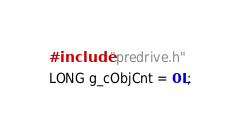Convert code to text. <code><loc_0><loc_0><loc_500><loc_500><_C++_>#include "predrive.h"
LONG g_cObjCnt = 0L;</code> 